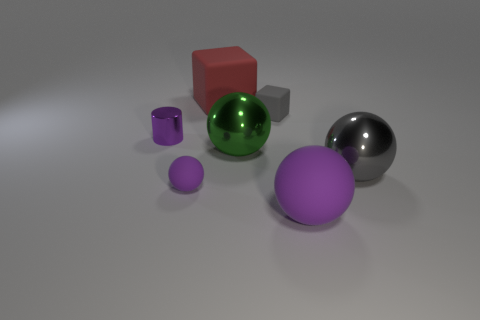Subtract all large green spheres. How many spheres are left? 3 Add 2 cyan shiny spheres. How many objects exist? 9 Subtract all red cubes. How many cubes are left? 1 Subtract all cylinders. How many objects are left? 6 Subtract 1 cylinders. How many cylinders are left? 0 Subtract all blue cylinders. Subtract all cyan spheres. How many cylinders are left? 1 Subtract all red cylinders. How many cyan balls are left? 0 Subtract all gray matte blocks. Subtract all large gray metal objects. How many objects are left? 5 Add 5 large purple matte things. How many large purple matte things are left? 6 Add 5 big green matte things. How many big green matte things exist? 5 